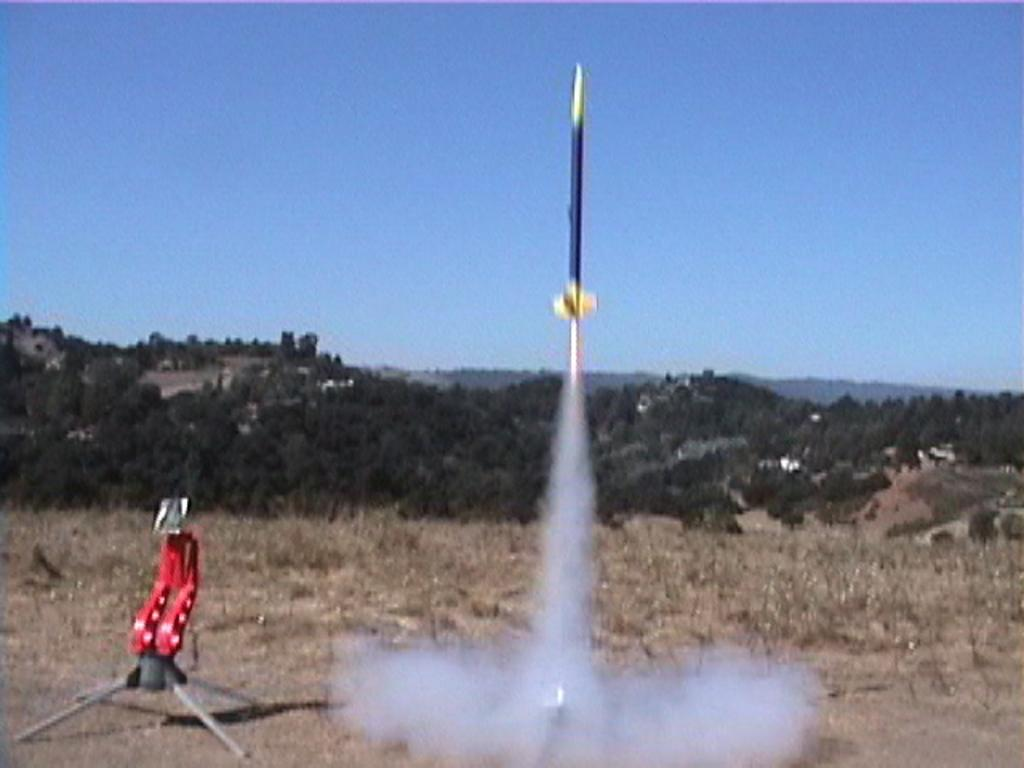What is the main subject of the image? There is a rocket in the image. What can be seen coming from the rocket? There is smoke in the image. What is located beside the smoke? There is an object beside the smoke. What type of vegetation is visible behind the rocket? There are groups of trees behind the rocket. What type of geographical feature is visible behind the rocket? There are mountains behind the rocket. What is visible at the top of the image? The sky is visible at the top of the image. What is the result of adding 2 and 3 in the image? There is no addition problem present in the image. Why is the rocket crying in the image? The rocket is not crying in the image; it is a non-living object and does not have emotions. 